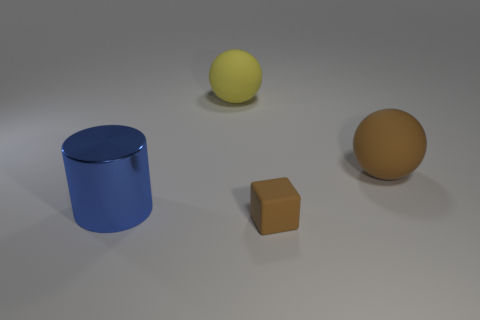The other big matte object that is the same shape as the yellow matte object is what color?
Provide a succinct answer. Brown. Are there fewer large brown things than small yellow rubber things?
Offer a very short reply. No. There is a block; is its size the same as the brown thing behind the big blue metallic cylinder?
Offer a terse response. No. There is a tiny rubber object that is right of the object that is to the left of the big yellow ball; what color is it?
Your response must be concise. Brown. How many objects are big spheres that are to the right of the rubber block or rubber spheres on the left side of the tiny object?
Your response must be concise. 2. Is the yellow object the same size as the blue shiny thing?
Give a very brief answer. Yes. Is there any other thing that has the same size as the matte cube?
Make the answer very short. No. Is the shape of the brown thing that is behind the large blue metal object the same as the rubber object that is on the left side of the small rubber thing?
Give a very brief answer. Yes. How big is the cylinder?
Offer a terse response. Large. There is a object that is left of the ball that is behind the big ball to the right of the large yellow matte thing; what is its material?
Offer a terse response. Metal. 